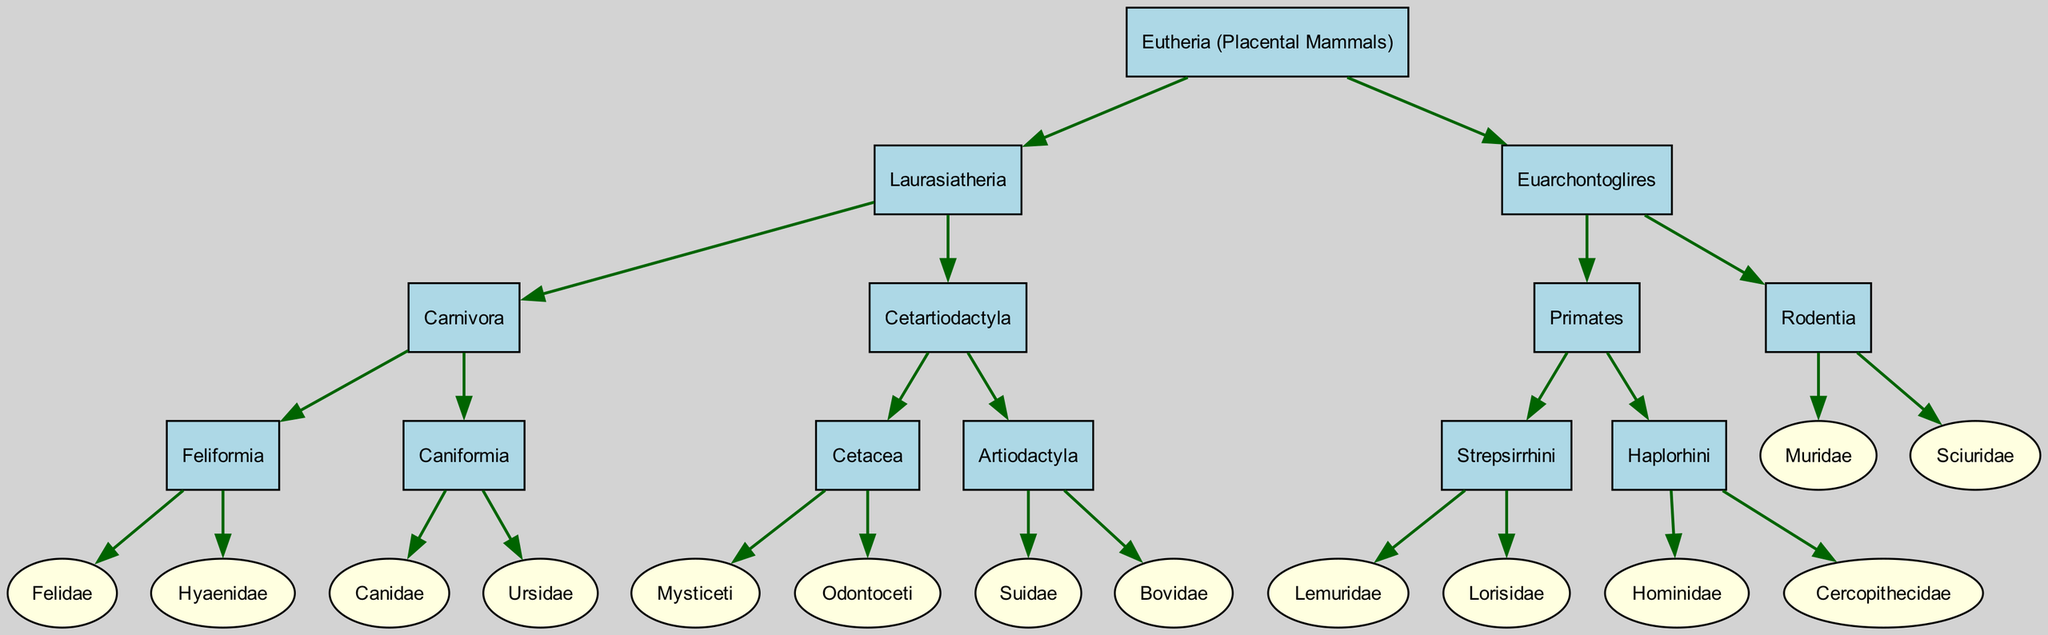What is the root of the phylogenetic tree? The root of the tree is the highest point, representing the most ancestral group. According to the diagram, the root is labeled "Eutheria (Placental Mammals)."
Answer: Eutheria (Placental Mammals) How many main branches are there in the tree? The main branches are the two large categories expanding from the root, which are Laurasiatheria and Euarchontoglires. Thus, there are two main branches.
Answer: 2 Which group contains the family Felidae? The family Felidae is a child of Feliformia, which is a child of Carnivora, which is a child of Laurasiatheria. This process involves moving down the tree structure to locate Felidae.
Answer: Carnivora What is the relationship between Primates and Rodentia? Primates and Rodentia are both children of the Euarchontoglires node, indicating that they share a common ancestor within this group.
Answer: Siblings Which group includes the families Suidae and Bovidae? By examining the tree, Suidae and Bovidae are found as children of the Artiodactyla node, which is within the Cetartiodactyla branch. Thus, both families belong to Cetartiodactyla.
Answer: Cetartiodactyla What type of mammal is represented by the family Hominidae? To find the type of mammal, we trace Hominidae up to its node, which falls under the order Primates. Therefore, the type of mammal for Hominidae is primate.
Answer: Primate How many families are represented under the order Carnivora? The Carnivora order is shown to have two distinct groups: Feliformia and Caniformia, with each group further divided into two families. Therefore, there are four families in total under Carnivora.
Answer: 4 Which two subgroups are part of Cetacea? The cetacean subclass is divided into two subgroups, Mysticeti and Odontoceti, which are found as children of the Cetacea node. Therefore, those are the two subgroups.
Answer: Mysticeti and Odontoceti What is the shape used to represent families in the diagram? The diagram indicates that families without children are displayed as ellipses, while nodes with children are represented as boxes. Therefore, families are represented by ellipses and child nodes by boxes.
Answer: Ellipses 